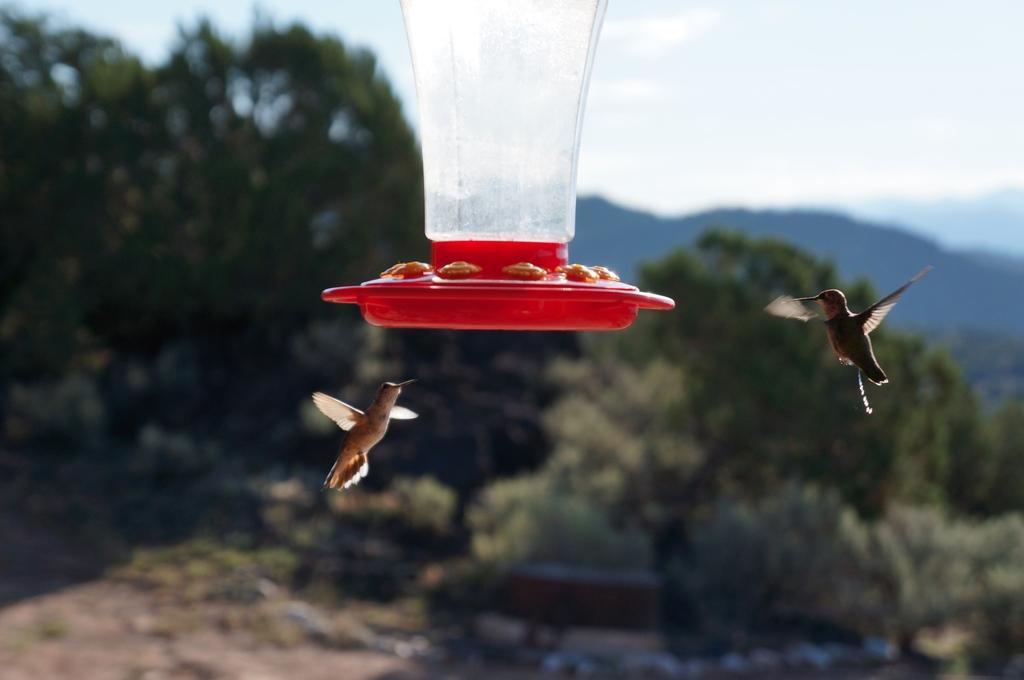Could you give a brief overview of what you see in this image? At the top of this image I can see an object which is looking like a jar. It is in white and red colors. Beside this two birds are flying in the air. In the background, I can see the trees and sky. 